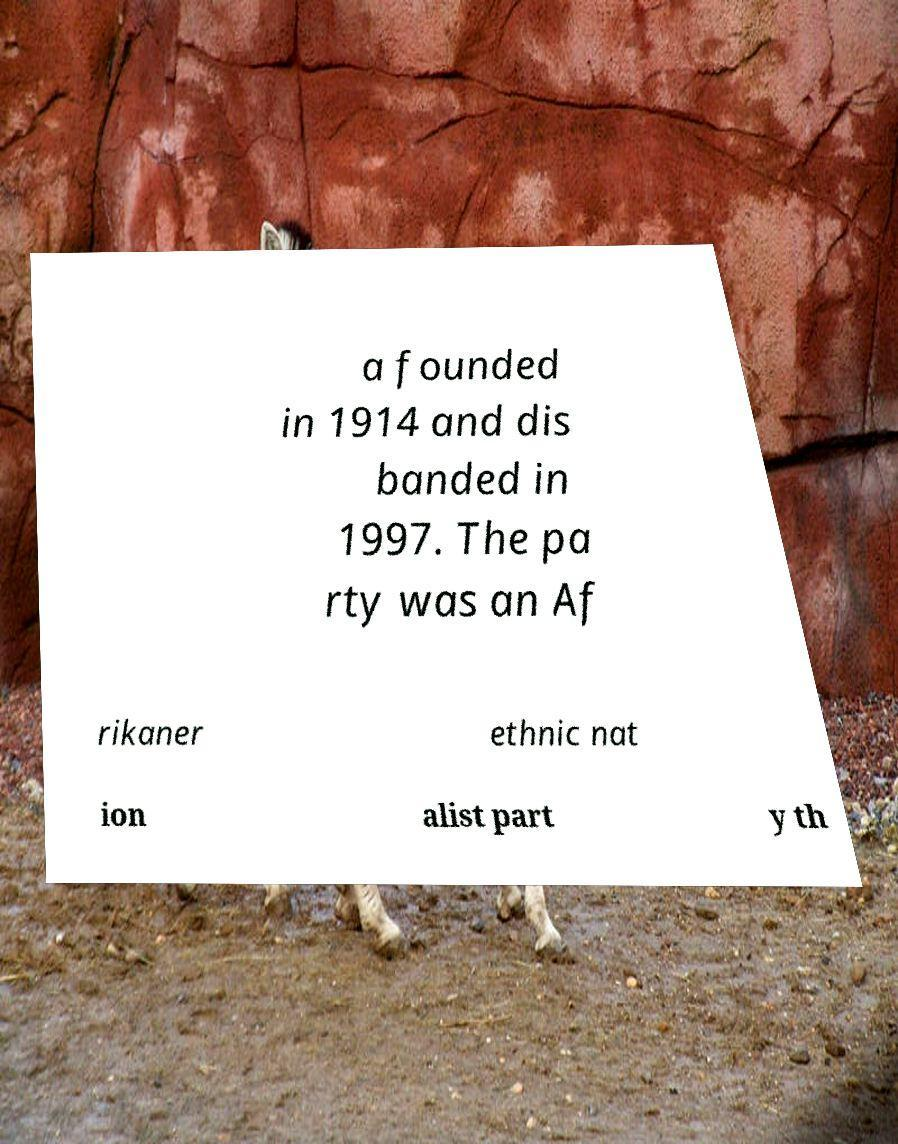Please read and relay the text visible in this image. What does it say? a founded in 1914 and dis banded in 1997. The pa rty was an Af rikaner ethnic nat ion alist part y th 